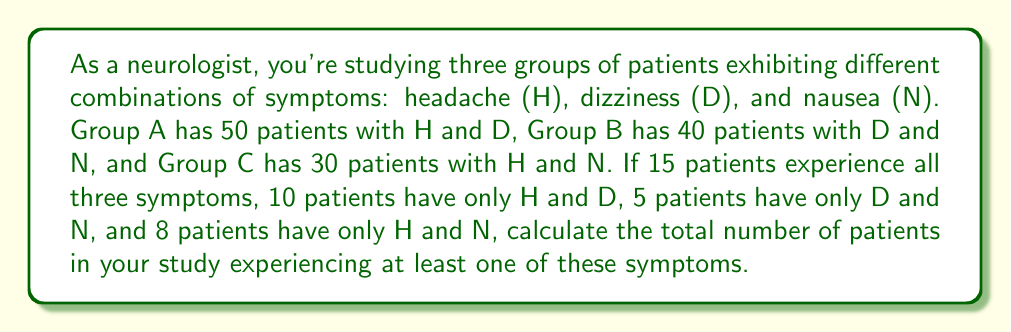Can you answer this question? Let's approach this step-by-step using set theory:

1) First, let's define our sets:
   H: patients with headache
   D: patients with dizziness
   N: patients with nausea

2) We're given the following information:
   $|H \cap D| = 50$
   $|D \cap N| = 40$
   $|H \cap N| = 30$
   $|H \cap D \cap N| = 15$
   $|H \cap D \setminus N| = 10$
   $|D \cap N \setminus H| = 5$
   $|H \cap N \setminus D| = 8$

3) We need to find $|H \cup D \cup N|$. We can use the inclusion-exclusion principle:

   $|H \cup D \cup N| = |H| + |D| + |N| - |H \cap D| - |H \cap N| - |D \cap N| + |H \cap D \cap N|$

4) We don't know $|H|$, $|D|$, or $|N|$ directly, but we can calculate them:

   $|H| = |H \cap D \setminus N| + |H \cap N \setminus D| + |H \cap D \cap N| + x$
   where $x$ is the number of patients with only H.
   
   Similarly for $|D|$ and $|N|$.

5) Let's calculate $|H|$:
   $|H| = 10 + 8 + 15 + x = 33 + x$

   Similarly:
   $|D| = 10 + 5 + 15 + y = 30 + y$
   $|N| = 5 + 8 + 15 + z = 28 + z$

   where $y$ and $z$ are the number of patients with only D and only N respectively.

6) Substituting into the inclusion-exclusion formula:

   $|H \cup D \cup N| = (33+x) + (30+y) + (28+z) - 50 - 30 - 40 + 15$

7) Simplifying:

   $|H \cup D \cup N| = 91 + x + y + z - 105 = x + y + z - 14$

8) The value $x + y + z$ represents the number of patients with only one symptom. We don't need to know this exact value to find the total.

9) The total number of patients is the sum of those with:
   - All three symptoms: 15
   - Exactly two symptoms: 10 + 5 + 8 = 23
   - Only one symptom: $x + y + z$

Therefore, $|H \cup D \cup N| = 15 + 23 + (x + y + z) = 38 + (x + y + z)$

This equals our formula from step 7: $x + y + z - 14 = 38 + (x + y + z)$
Answer: The total number of patients experiencing at least one of these symptoms is 52. 